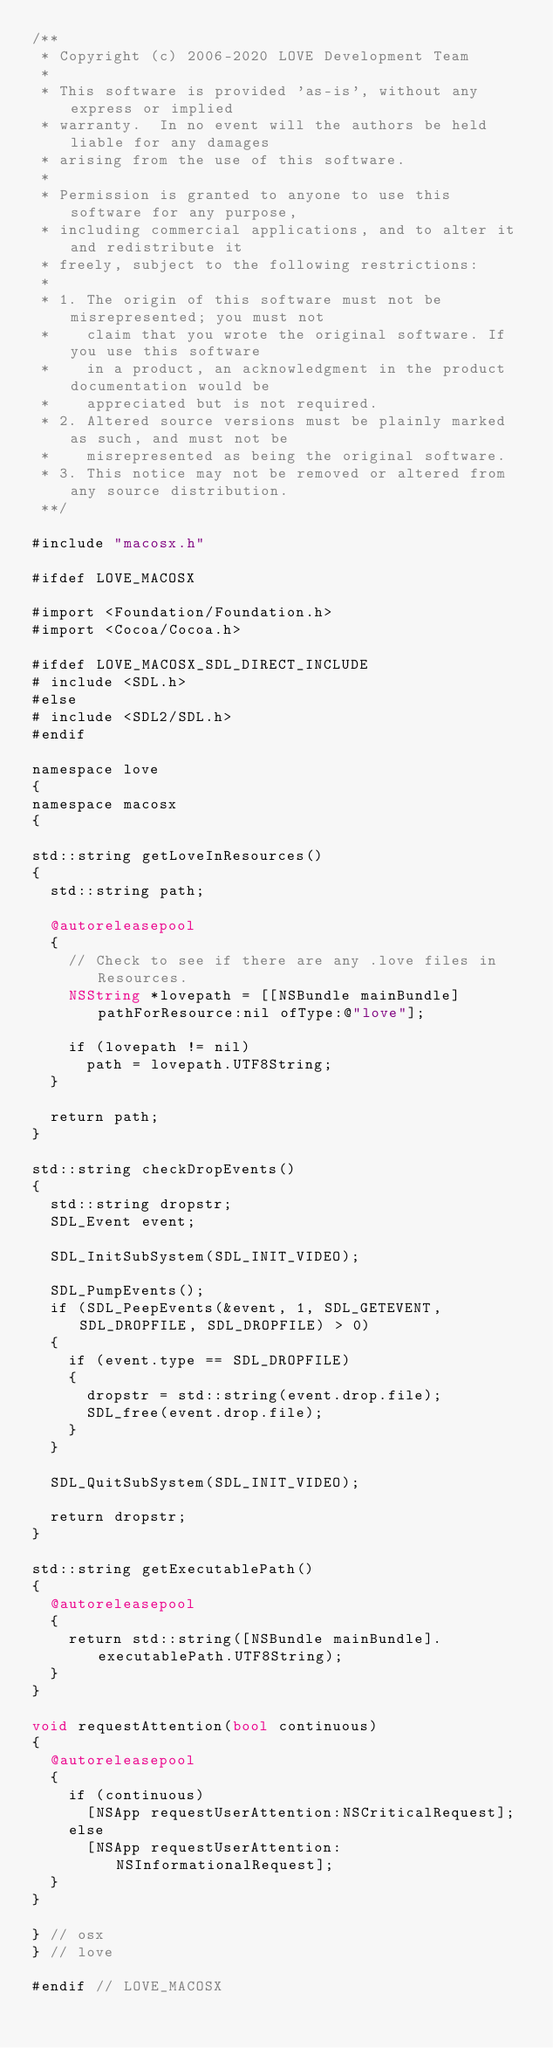<code> <loc_0><loc_0><loc_500><loc_500><_ObjectiveC_>/**
 * Copyright (c) 2006-2020 LOVE Development Team
 *
 * This software is provided 'as-is', without any express or implied
 * warranty.  In no event will the authors be held liable for any damages
 * arising from the use of this software.
 *
 * Permission is granted to anyone to use this software for any purpose,
 * including commercial applications, and to alter it and redistribute it
 * freely, subject to the following restrictions:
 *
 * 1. The origin of this software must not be misrepresented; you must not
 *    claim that you wrote the original software. If you use this software
 *    in a product, an acknowledgment in the product documentation would be
 *    appreciated but is not required.
 * 2. Altered source versions must be plainly marked as such, and must not be
 *    misrepresented as being the original software.
 * 3. This notice may not be removed or altered from any source distribution.
 **/

#include "macosx.h"

#ifdef LOVE_MACOSX

#import <Foundation/Foundation.h>
#import <Cocoa/Cocoa.h>

#ifdef LOVE_MACOSX_SDL_DIRECT_INCLUDE
# include <SDL.h>
#else
# include <SDL2/SDL.h>
#endif

namespace love
{
namespace macosx
{

std::string getLoveInResources()
{
	std::string path;

	@autoreleasepool
	{
		// Check to see if there are any .love files in Resources.
		NSString *lovepath = [[NSBundle mainBundle] pathForResource:nil ofType:@"love"];

		if (lovepath != nil)
			path = lovepath.UTF8String;
	}

	return path;
}

std::string checkDropEvents()
{
	std::string dropstr;
	SDL_Event event;

	SDL_InitSubSystem(SDL_INIT_VIDEO);

	SDL_PumpEvents();
	if (SDL_PeepEvents(&event, 1, SDL_GETEVENT, SDL_DROPFILE, SDL_DROPFILE) > 0)
	{
		if (event.type == SDL_DROPFILE)
		{
			dropstr = std::string(event.drop.file);
			SDL_free(event.drop.file);
		}
	}

	SDL_QuitSubSystem(SDL_INIT_VIDEO);

	return dropstr;
}

std::string getExecutablePath()
{
	@autoreleasepool
	{
		return std::string([NSBundle mainBundle].executablePath.UTF8String);
	}
}

void requestAttention(bool continuous)
{
	@autoreleasepool
	{
		if (continuous)
			[NSApp requestUserAttention:NSCriticalRequest];
		else
			[NSApp requestUserAttention:NSInformationalRequest];
	}
}

} // osx
} // love

#endif // LOVE_MACOSX
</code> 